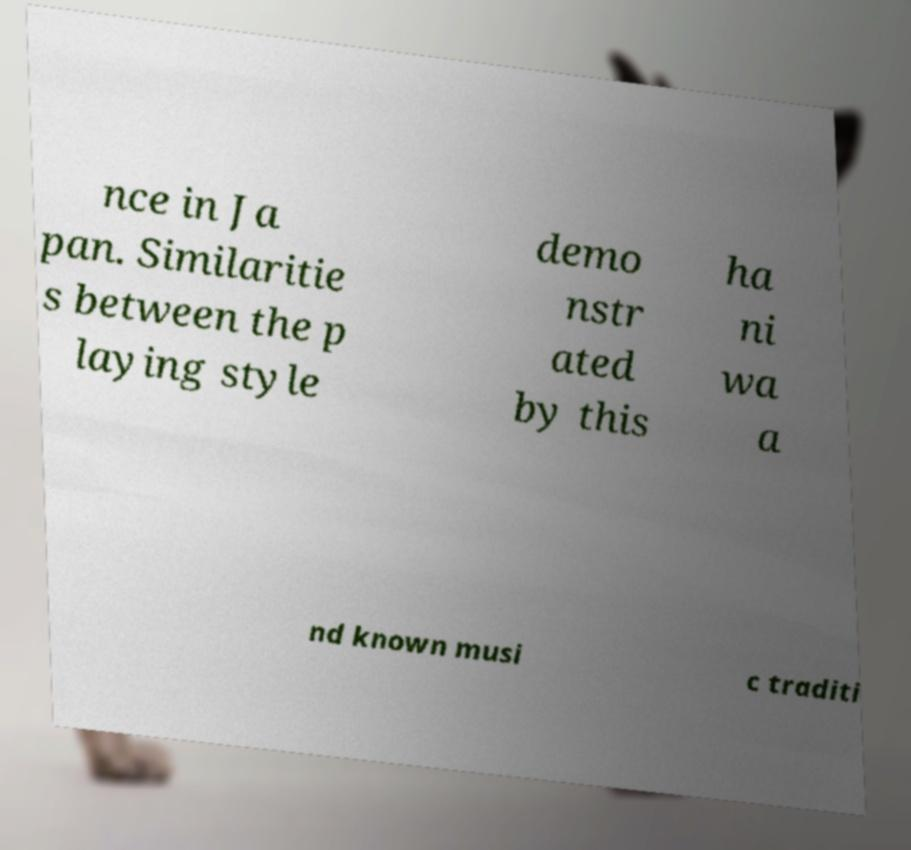Could you extract and type out the text from this image? nce in Ja pan. Similaritie s between the p laying style demo nstr ated by this ha ni wa a nd known musi c traditi 